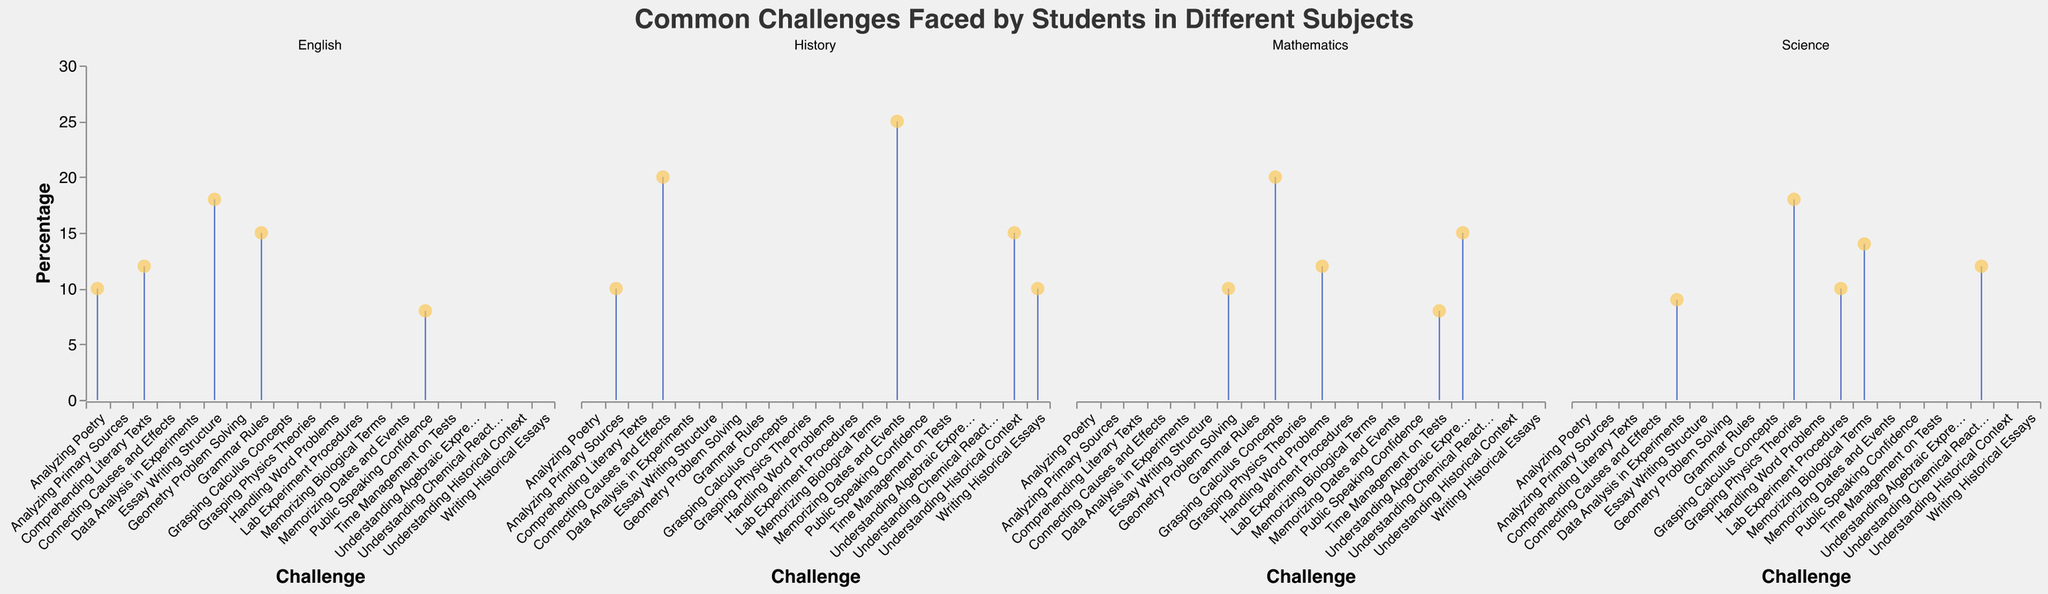What is the title of the figure? The title is usually found at the top of the figure, displaying the main topic or the overall theme being visualized. In this case, looking at the specified figure, the title is "Common Challenges Faced by Students in Different Subjects".
Answer: "Common Challenges Faced by Students in Different Subjects" How many challenges are listed under the subject 'English'? To find this, look at the section of the plot labeled 'English' and count the number of different challenges listed along the x-axis. There are 5 challenges mentioned: "Comprehending Literary Texts", "Grammar Rules", "Essay Writing Structure", "Public Speaking Confidence", and "Analyzing Poetry".
Answer: 5 Which challenge has the highest percentage in the 'History' subject? Focus on the 'History' section in the plot and look for the challenge with the highest bar or point along the y-axis. The challenge "Memorizing Dates and Events" clearly has the highest percentage of 25%.
Answer: Memorizing Dates and Events What is the combined percentage of the top two challenges in 'Mathematics'? Find the top two challenges with the highest percentages in the 'Mathematics' section. They are "Grasping Calculus Concepts" with 20% and "Understanding Algebraic Expressions" with 15%. Sum these percentages: 20% + 15% = 35%.
Answer: 35% Among the subjects listed, which has the challenge with the lowest recorded percentage, and what is that challenge? Scan across all subjects to find the challenge with the lowest y-axis value. In 'Mathematics', the challenge "Time Management on Tests" has the lowest percentage at 8%, which is also the lowest in all subjects.
Answer: Mathematics, Time Management on Tests How does the percentage for 'Public Speaking Confidence' in English compare to 'Lab Experiment Procedures' in Science? Compare the two challenges directly. 'Public Speaking Confidence' in English is at 8%, while 'Lab Experiment Procedures' in Science is at 10%. Thus, 'Public Speaking Confidence' has a lower percentage by 2%.
Answer: Public Speaking Confidence is 2% lower than Lab Experiment Procedures What is the average percentage of challenges in 'Science'? To find the average, add up all the percentages for challenges under 'Science' and then divide by the number of challenges. The percentages are 18, 12, 14, 10, and 9. Sum them: 18 + 12 + 14 + 10 + 9 = 63. Then divide by 5: 63/5 = 12.6.
Answer: 12.6% Which subject has the most evenly distributed challenge percentages based on visual inspection? 'Science' and 'English' have the most variations of percentages but 'History' where most challenges have similar percentages around them, making it appear as the most evenly distributed upon visual inspection (percentages vary less).
Answer: History Compare the highest percentages among all four subjects. Which subjects have their highest percentages closest in value, and what are those values? Calculate and compare the highest percentages for each subject:
- Mathematics: 20% (Grasping Calculus Concepts)
- Science: 18% (Grasping Physics Theories)
- English: 18% (Essay Writing Structure)
- History: 25% (Memorizing Dates and Events)
The highest percentages of Science and English are closest, both at 18%.
Answer: Science and English, both 18% Which challenge presents a greater struggle: 'Memorizing Biological Terms' in Science or 'Understanding Historical Context' in History? Compare the respective percentages: 'Memorizing Biological Terms' in Science is at 14%, and 'Understanding Historical Context' in History is at 15%. Hence, 'Understanding Historical Context' presents a slightly greater struggle.
Answer: Understanding Historical Context 